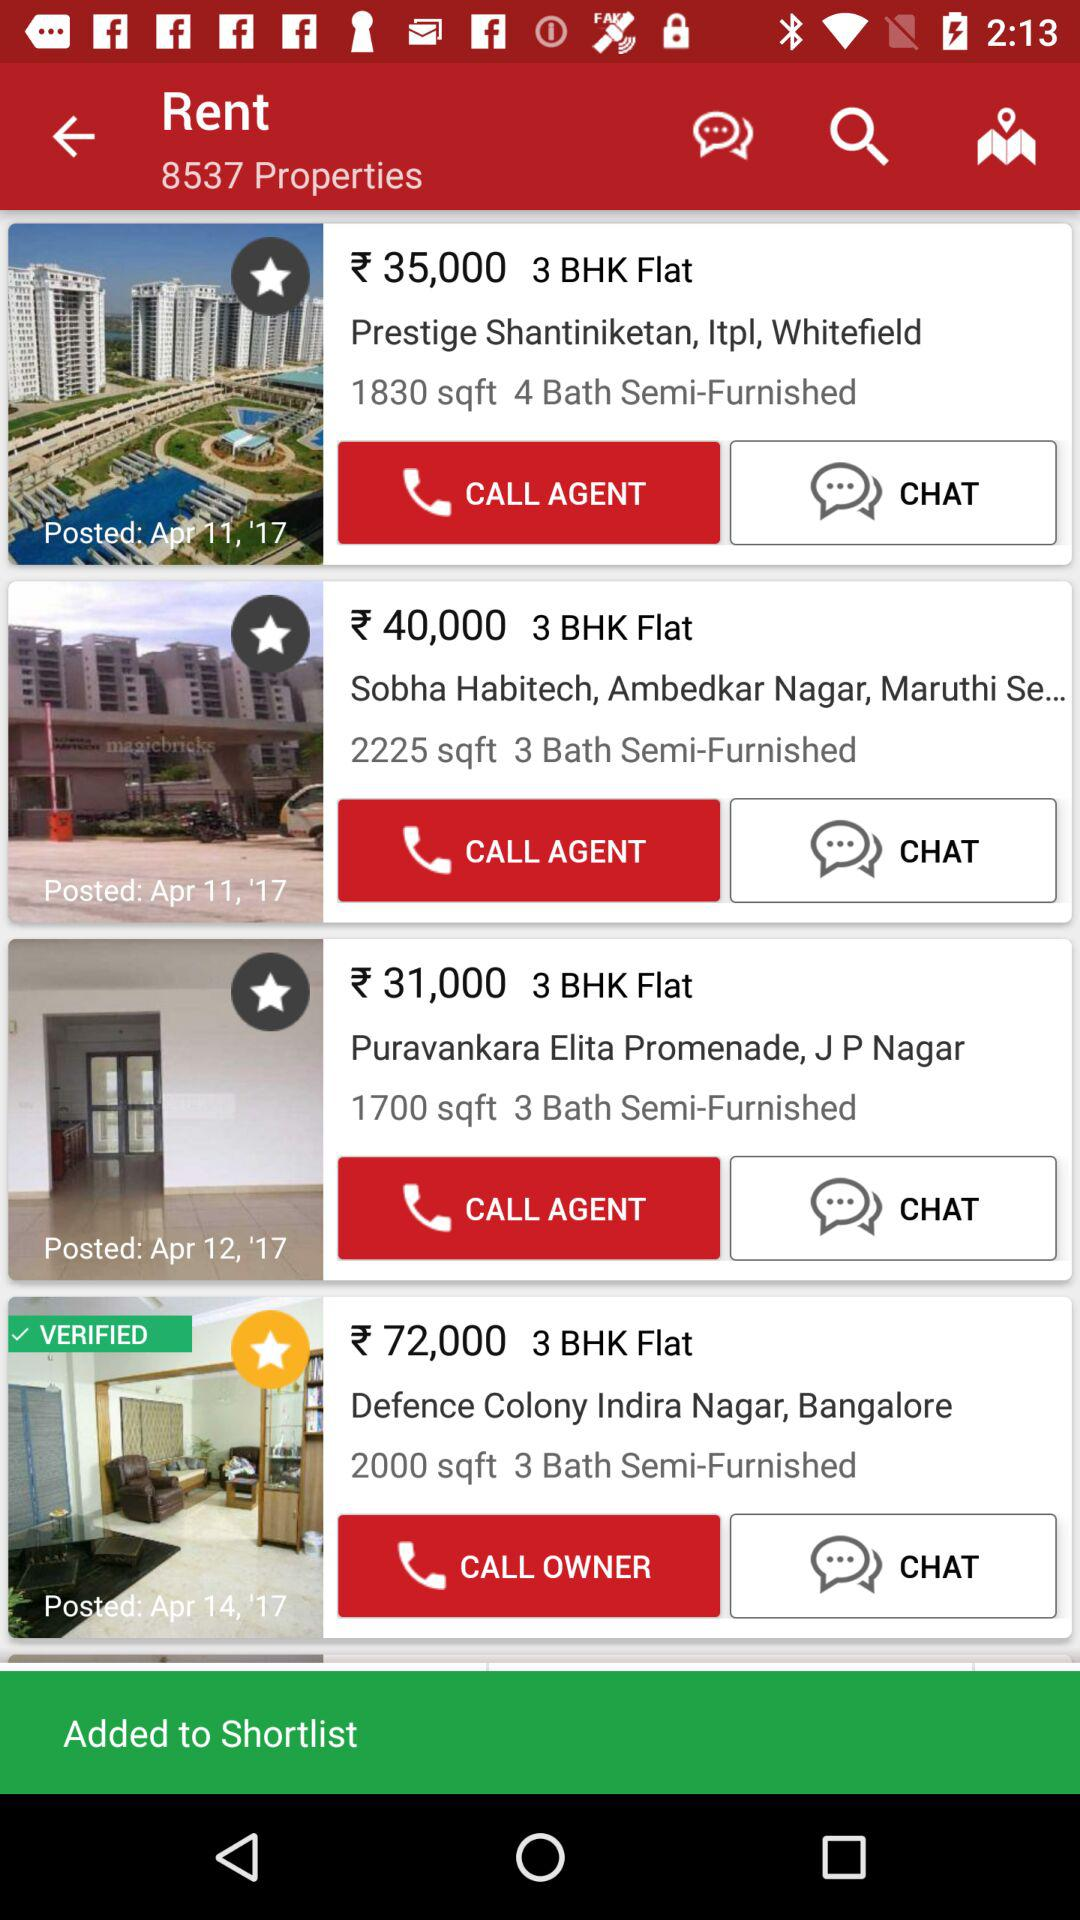How many properties are there on the results page?
Answer the question using a single word or phrase. 4 